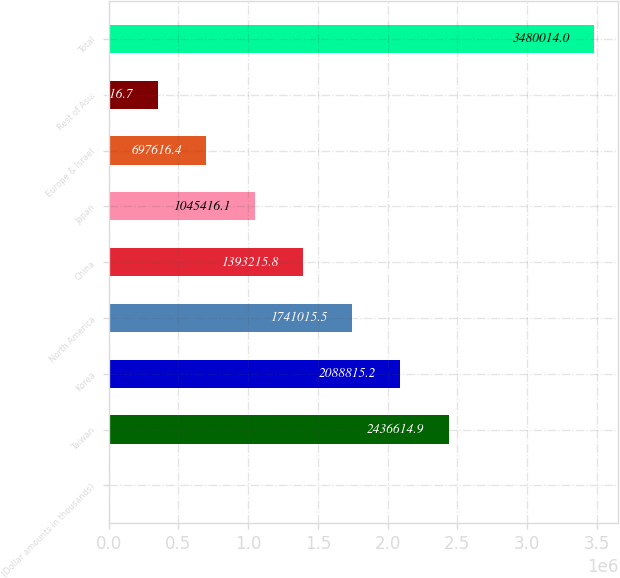<chart> <loc_0><loc_0><loc_500><loc_500><bar_chart><fcel>(Dollar amounts in thousands)<fcel>Taiwan<fcel>Korea<fcel>North America<fcel>China<fcel>Japan<fcel>Europe & Israel<fcel>Rest of Asia<fcel>Total<nl><fcel>2017<fcel>2.43661e+06<fcel>2.08882e+06<fcel>1.74102e+06<fcel>1.39322e+06<fcel>1.04542e+06<fcel>697616<fcel>349817<fcel>3.48001e+06<nl></chart> 